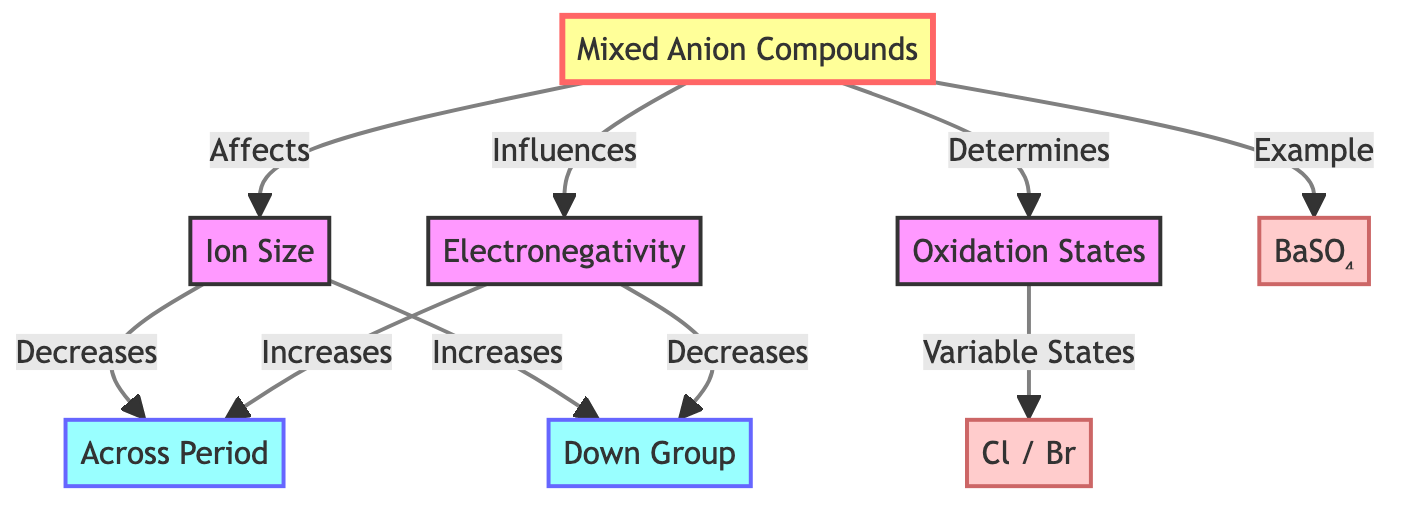What are the three primary factors that relate to mixed anion compounds? The diagram shows three primary factors: ion size, electronegativity, and oxidation states. These are explicitly listed as they are directly affected, influenced, or determined by mixed anion compounds.
Answer: Ion Size, Electronegativity, Oxidation States How does ion size change as you move across a period? The diagram indicates that ion size decreases across a period. This relationship is conveyed through the direct connection from ion size to the horizontal trend, labeled "Decreases."
Answer: Decreases What is the example of a mixed anion compound shown in the diagram? The diagram provides an explicit example of a mixed anion compound: BaSO₄. It is connected to the anion compound node with the label "Example."
Answer: BaSO₄ How does electronegativity change as you move down a group? According to the diagram, electronegativity decreases down a group. This is specified through the connection from electronegativity to the vertical trend, which indicates "Decreases."
Answer: Decreases What is the relationship between mixed anion compounds and oxidation states? The diagram states that mixed anion compounds determine oxidation states. This is indicated by the direct connection from the anion compound to oxidation states with the label "Determines."
Answer: Determines How do ion sizes differ vertically in groups on the periodic table? The diagram illustrates that ion size increases as you move down a group. This is denoted by the connection from ion size to the vertical trend, which shows "Increases."
Answer: Increases What trend is noted for electronegativity across a period? The diagram indicates that electronegativity increases across a period. This is illustrated by the direct link from electronegativity to the horizontal trend, which states "Increases."
Answer: Increases Which anions are associated with variable oxidation states according to the diagram? The diagram cites the anions Cl and Br as having variable oxidation states. This is explicitly labeled as the connection from oxidation states to the example shown as "Cl / Br."
Answer: Cl / Br 